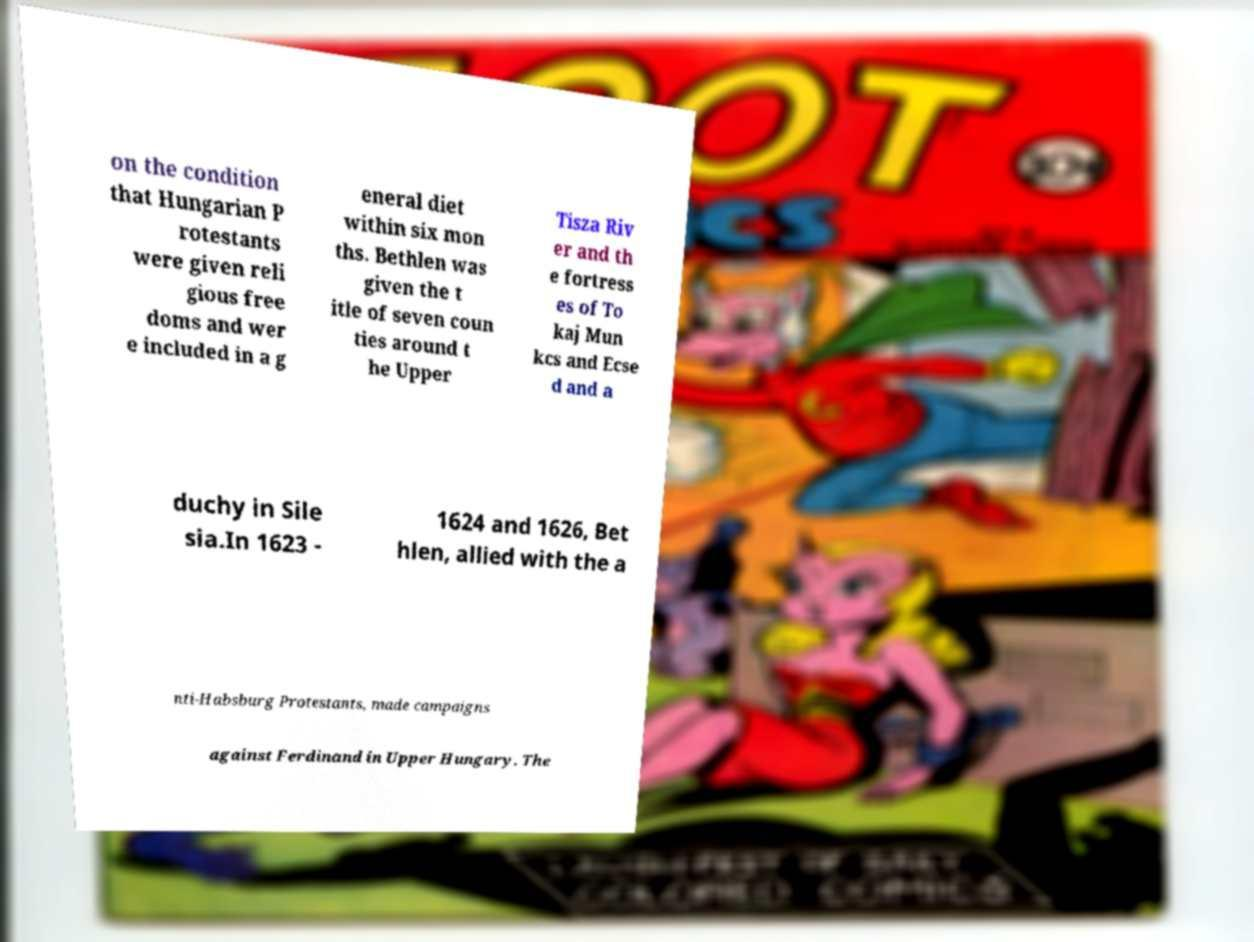I need the written content from this picture converted into text. Can you do that? on the condition that Hungarian P rotestants were given reli gious free doms and wer e included in a g eneral diet within six mon ths. Bethlen was given the t itle of seven coun ties around t he Upper Tisza Riv er and th e fortress es of To kaj Mun kcs and Ecse d and a duchy in Sile sia.In 1623 - 1624 and 1626, Bet hlen, allied with the a nti-Habsburg Protestants, made campaigns against Ferdinand in Upper Hungary. The 